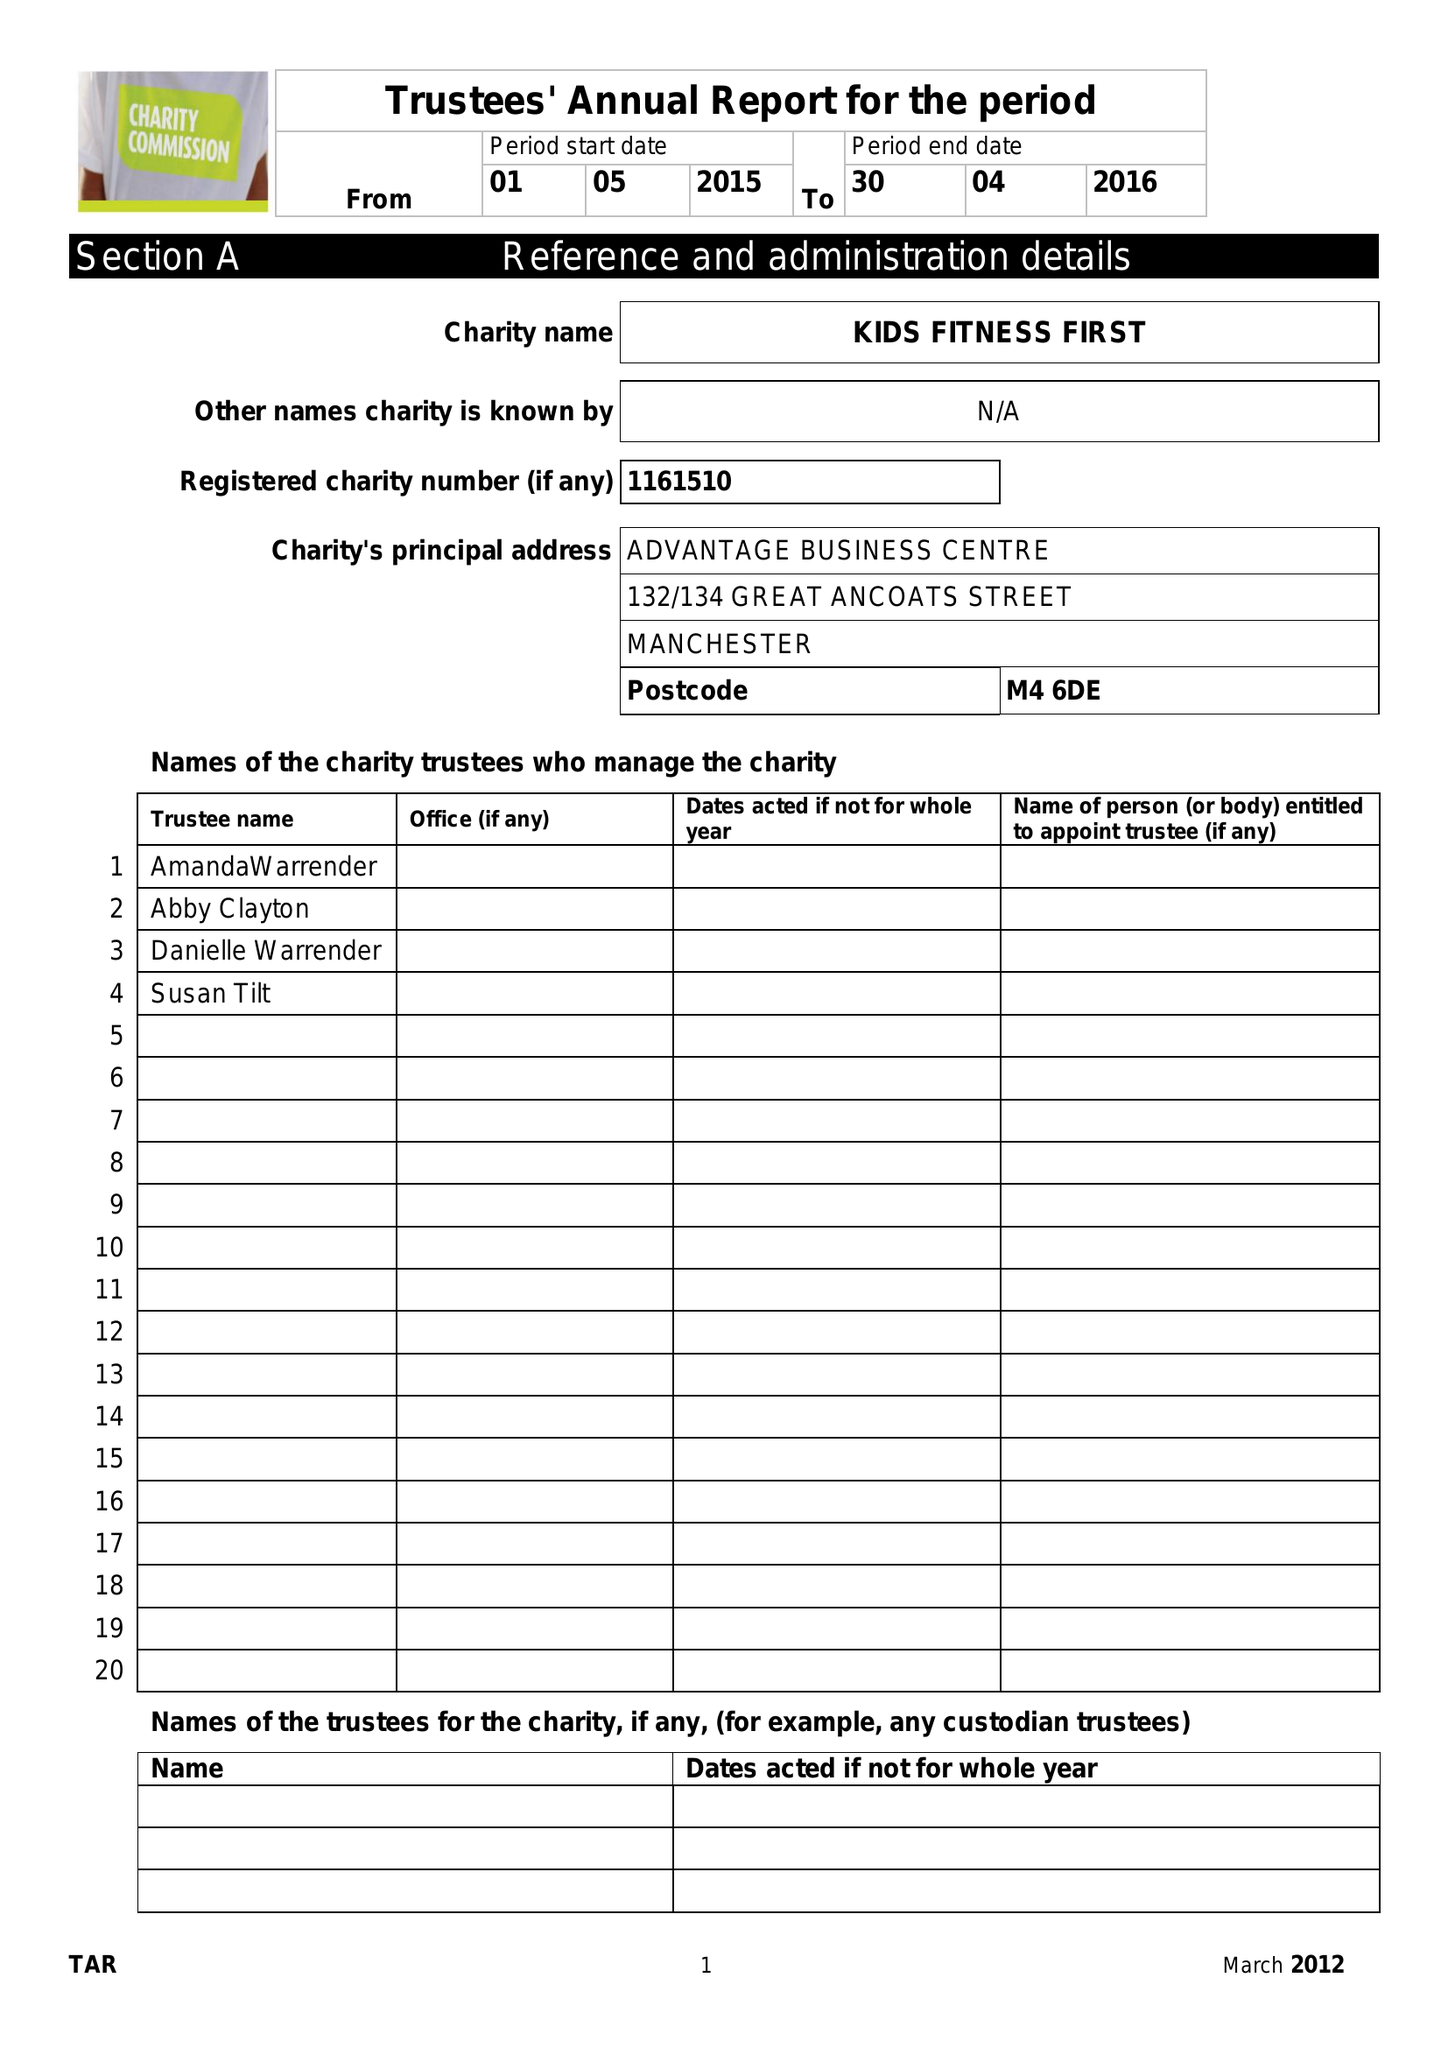What is the value for the charity_name?
Answer the question using a single word or phrase. Kids Fitness First 